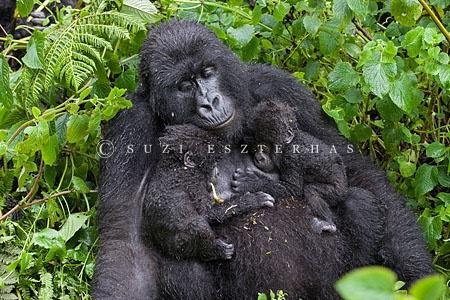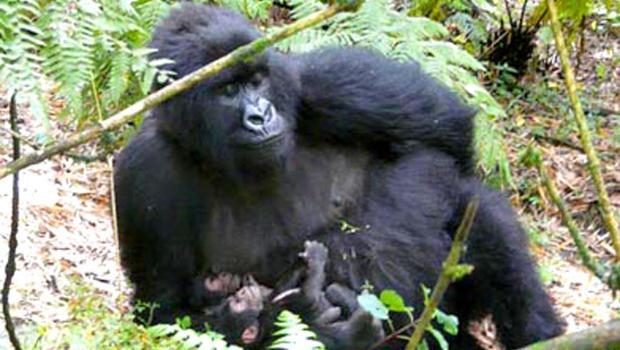The first image is the image on the left, the second image is the image on the right. Considering the images on both sides, is "Each image shows an upright adult gorilla with two baby gorillas in front of it, and at least one of the images shows the baby gorillas face-to-face and on the adult gorilla's chest." valid? Answer yes or no. Yes. The first image is the image on the left, the second image is the image on the right. Evaluate the accuracy of this statement regarding the images: "In each image, two baby gorillas are by their mother.". Is it true? Answer yes or no. Yes. 